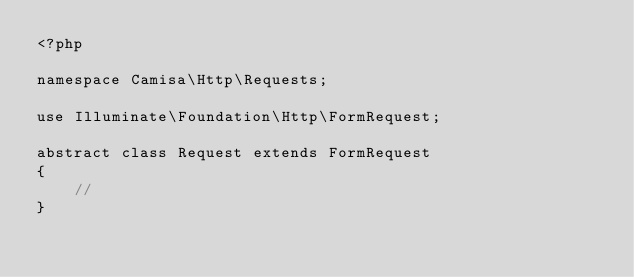Convert code to text. <code><loc_0><loc_0><loc_500><loc_500><_PHP_><?php

namespace Camisa\Http\Requests;

use Illuminate\Foundation\Http\FormRequest;

abstract class Request extends FormRequest
{
    //
}
</code> 